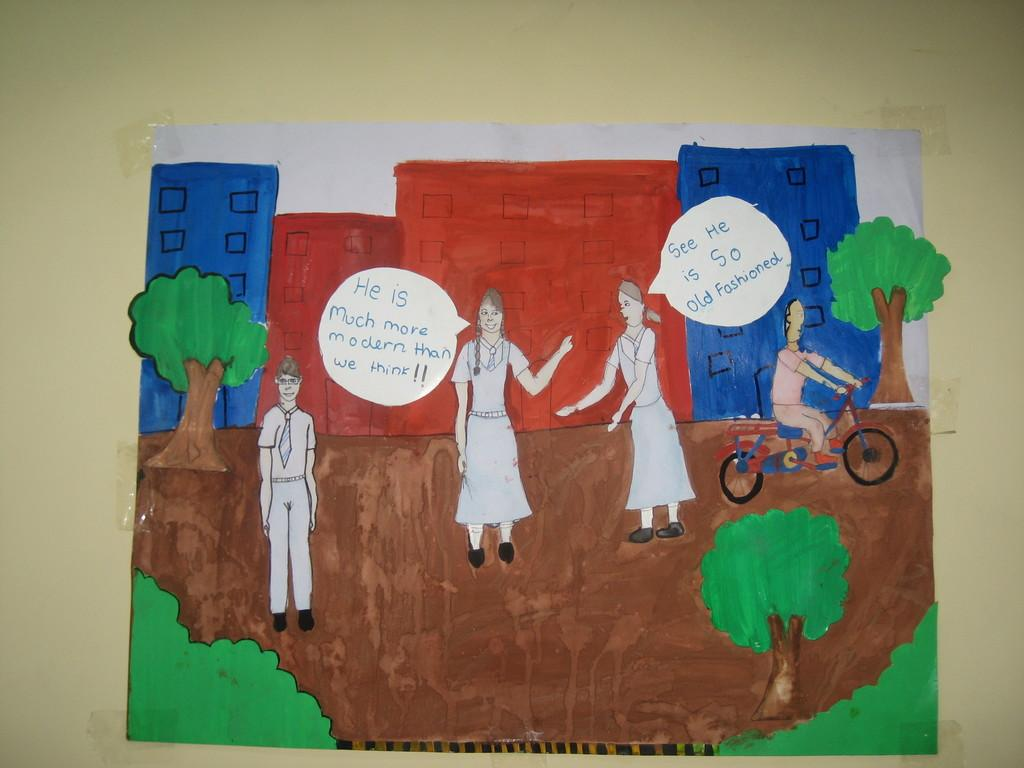What is on the wall in the image? There is a paper on the wall in the image. What is depicted on the paper? The paper contains paintings. How many planes are visible in the image? There are no planes visible in the image; it features a paper with paintings on the wall. What type of sack is being used to store the oatmeal in the image? There is no sack or oatmeal present in the image. 